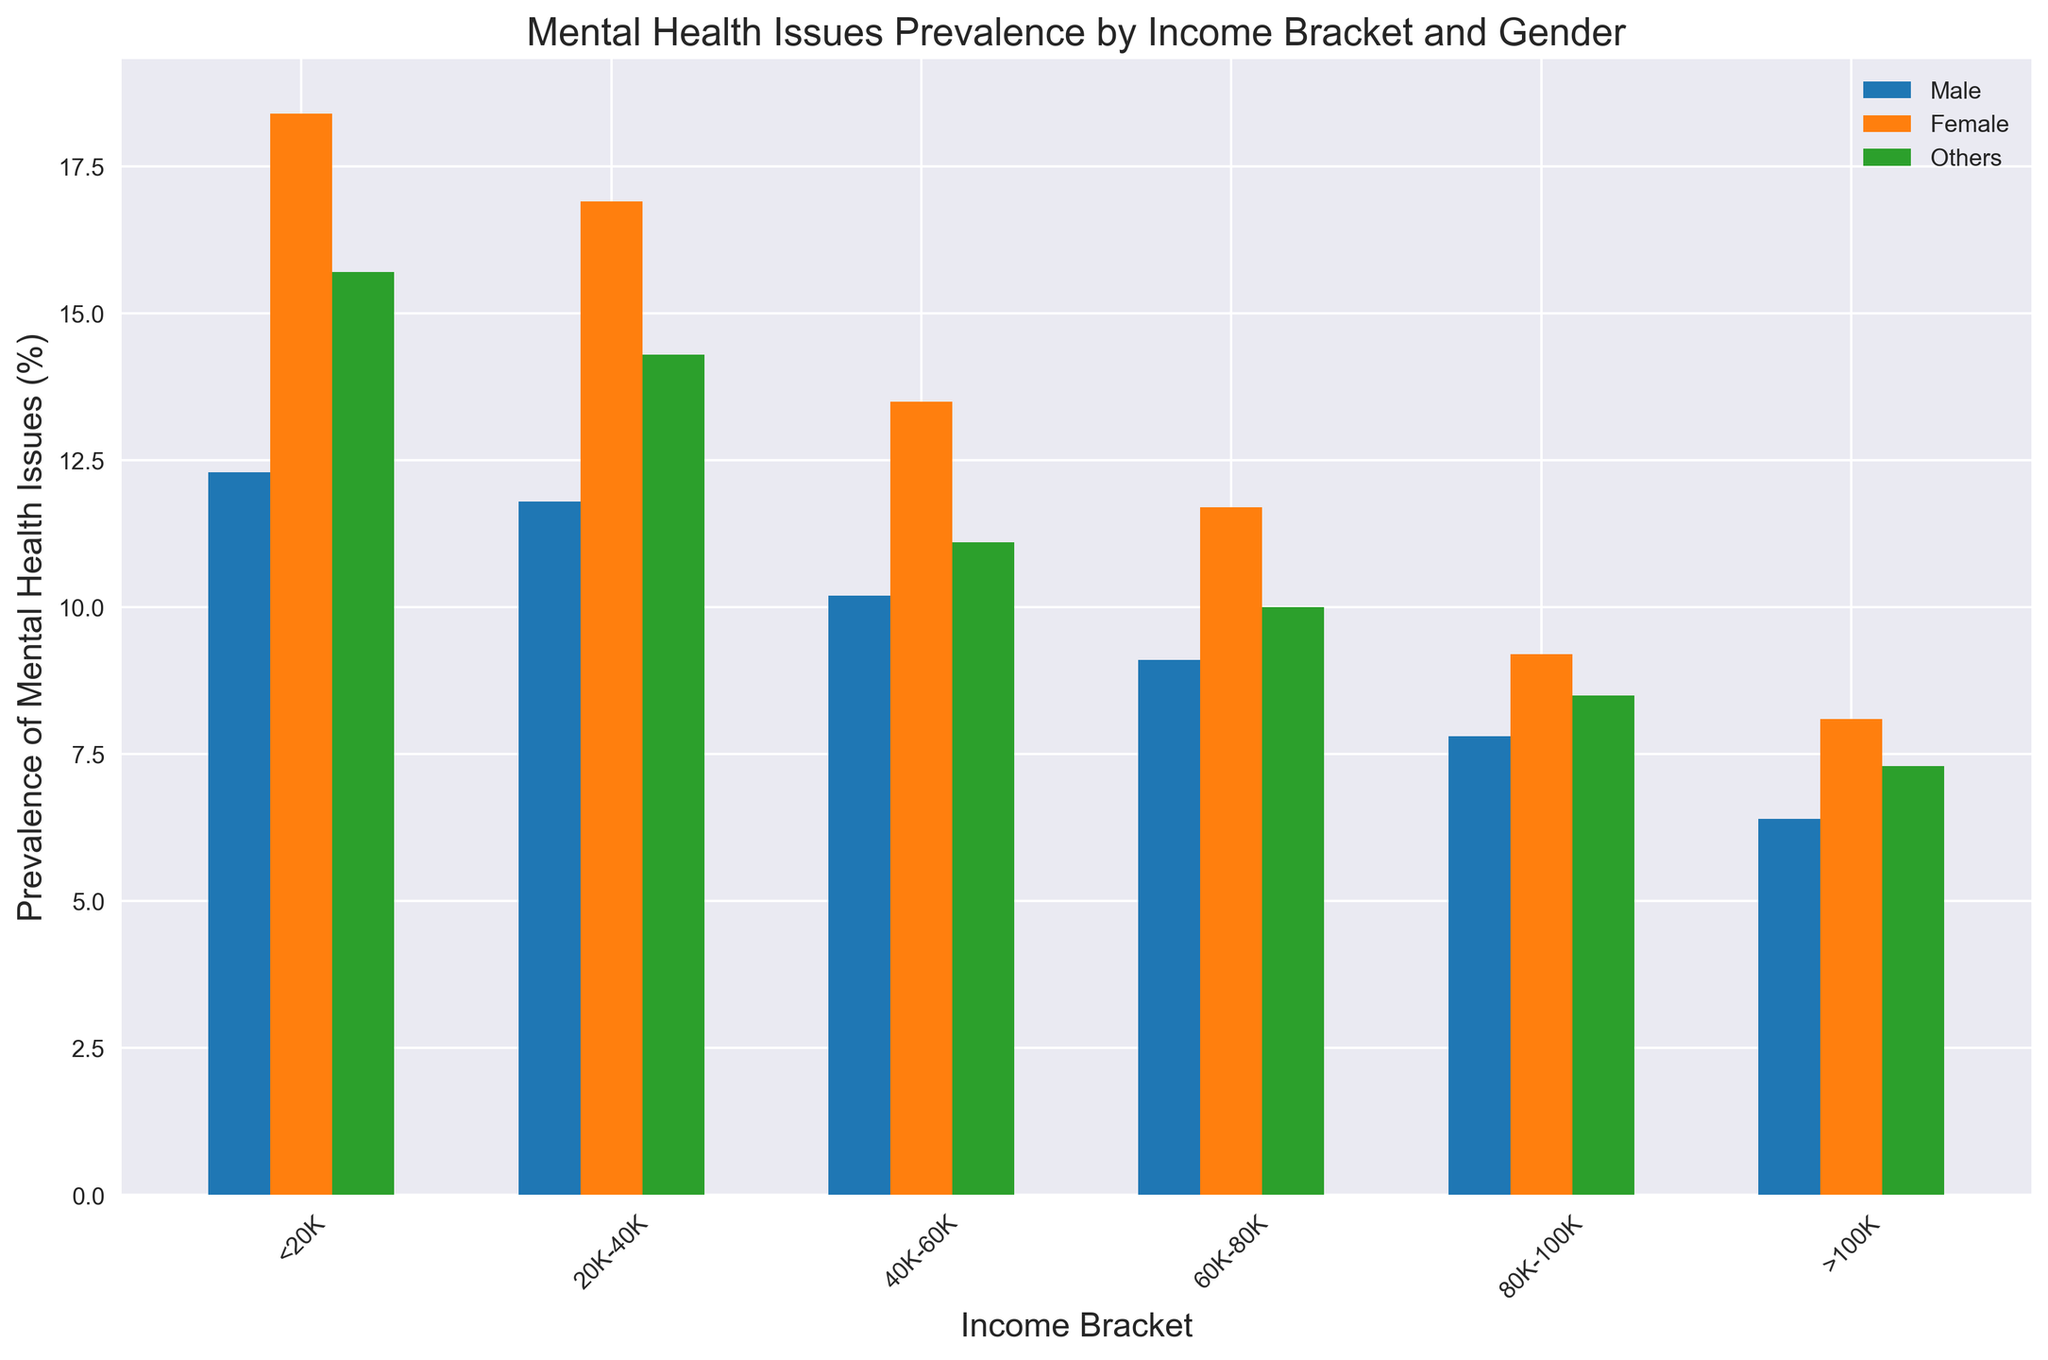What is the difference in prevalence of mental health issues between males and females in the <20K income bracket? Look at the bars for the <20K income bracket for both males and females. The male prevalence is 12.3% and the female prevalence is 18.4%. Subtract 12.3 from 18.4 to get the difference.
Answer: 6.1% Which gender has the highest prevalence of mental health issues in the >100K income bracket? Look at the bars for the >100K income bracket. Compare the heights of the bars for males (6.4%), females (8.1%), and others (7.3%). The tallest bar represents the females.
Answer: Female Between which income brackets does the prevalence of mental health issues for males decrease the most? Check the heights of the bars for males across different income brackets. Calculate the differences between each consecutive bracket: <20K to 20K-40K (12.3 - 11.8 = 0.5), 20K-40K to 40K-60K (11.8 - 10.2 = 1.6), 40K-60K to 60K-80K (10.2 - 9.1 = 1.1), 60K-80K to 80K-100K (9.1 - 7.8 = 1.3), 80K-100K to >100K (7.8 - 6.4 = 1.4). The largest decrease is between 20K-40K to 40K-60K.
Answer: 20K-40K to 40K-60K Calculate the average prevalence of mental health issues across all income brackets for the Others gender. Sum the prevalence values for the Others gender across all income brackets and divide by the number of brackets: (15.7 + 14.3 + 11.1 + 10.0 + 8.5 + 7.3) / 6 = 66.9 / 6.
Answer: 11.15% Is the prevalence of mental health issues for females always higher than that for males across all income brackets? Compare each pair of bars for males and females across all income brackets: <20K - Female (18.4%) > Male (12.3%), 20K-40K - Female (16.9%) > Male (11.8%), 40K-60K - Female (13.5%) > Male (10.2%), 60K-80K - Female (11.7%) > Male (9.1%), 80K-100K - Female (9.2%) > Male (7.8%), >100K - Female (8.1%) > Male (6.4%). Females have higher prevalence in all brackets.
Answer: Yes Which income bracket sees the smallest difference in prevalence of mental health issues between females and others? Subtract the prevalence for Others from the prevalence for Females in each bracket and find the smallest difference: <20K (18.4 - 15.7 = 2.7), 20K-40K (16.9 - 14.3 = 2.6), 40K-60K (13.5 - 11.1 = 2.4), 60K-80K (11.7 - 10.0 = 1.7), 80K-100K (9.2 - 8.5 = 0.7), >100K (8.1 - 7.3 = 0.8). The smallest difference is in the 80K-100K bracket.
Answer: 80K-100K What is the combined prevalence of mental health issues for all genders in the 40K-60K income bracket? Add the prevalence values for all genders in the 40K-60K income bracket: Male (10.2%) + Female (13.5%) + Others (11.1%) = 34.8.
Answer: 34.8% How much higher is the prevalence of mental health issues for females in the 20K-40K bracket compared to males in the 40K-60K bracket? Look at the bars for females in the 20K-40K bracket (16.9%) and males in the 40K-60K bracket (10.2%). Subtract 10.2 from 16.9 to get the difference.
Answer: 6.7% In which income bracket is the difference in prevalence between males and others the greatest? Subtract the prevalence for Others from the prevalence for Males in each bracket and find the greatest difference: <20K (12.3 - 15.7 = -3.4), 20K-40K (11.8 - 14.3 = -2.5), 40K-60K (10.2 - 11.1 = -0.9), 60K-80K (9.1 - 10.0 = -0.9), 80K-100K (7.8 - 8.5 = -0.7), >100K (6.4 - 7.3 = -0.9). The greatest difference is in the <20K bracket.
Answer: <20K 